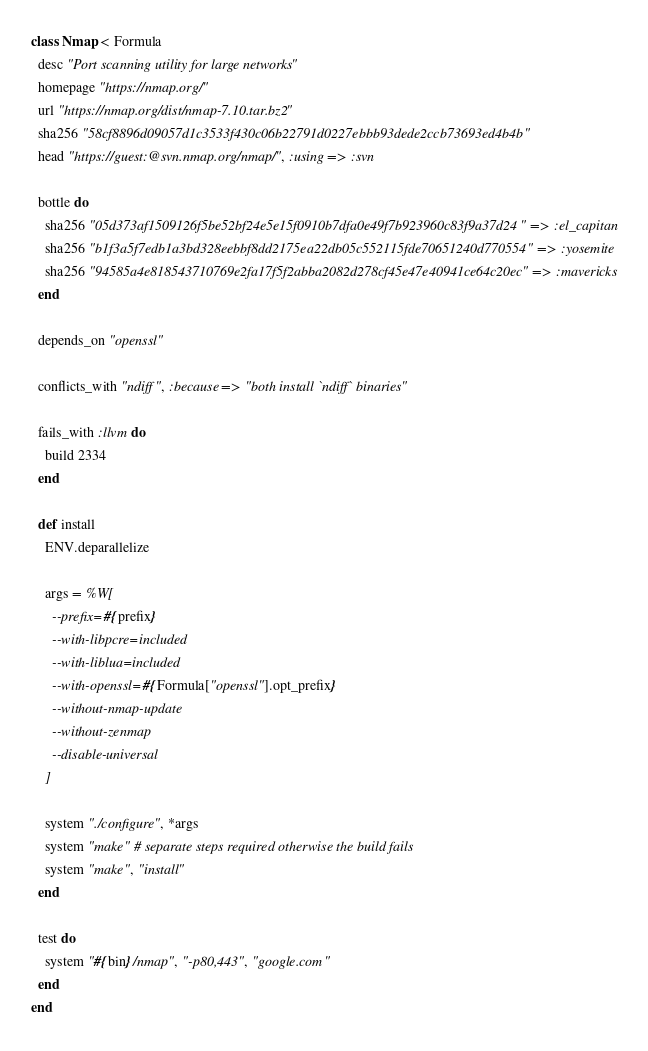Convert code to text. <code><loc_0><loc_0><loc_500><loc_500><_Ruby_>class Nmap < Formula
  desc "Port scanning utility for large networks"
  homepage "https://nmap.org/"
  url "https://nmap.org/dist/nmap-7.10.tar.bz2"
  sha256 "58cf8896d09057d1c3533f430c06b22791d0227ebbb93dede2ccb73693ed4b4b"
  head "https://guest:@svn.nmap.org/nmap/", :using => :svn

  bottle do
    sha256 "05d373af1509126f5be52bf24e5e15f0910b7dfa0e49f7b923960c83f9a37d24" => :el_capitan
    sha256 "b1f3a5f7edb1a3bd328eebbf8dd2175ea22db05c552115fde70651240d770554" => :yosemite
    sha256 "94585a4e818543710769e2fa17f5f2abba2082d278cf45e47e40941ce64c20ec" => :mavericks
  end

  depends_on "openssl"

  conflicts_with "ndiff", :because => "both install `ndiff` binaries"

  fails_with :llvm do
    build 2334
  end

  def install
    ENV.deparallelize

    args = %W[
      --prefix=#{prefix}
      --with-libpcre=included
      --with-liblua=included
      --with-openssl=#{Formula["openssl"].opt_prefix}
      --without-nmap-update
      --without-zenmap
      --disable-universal
    ]

    system "./configure", *args
    system "make" # separate steps required otherwise the build fails
    system "make", "install"
  end

  test do
    system "#{bin}/nmap", "-p80,443", "google.com"
  end
end
</code> 